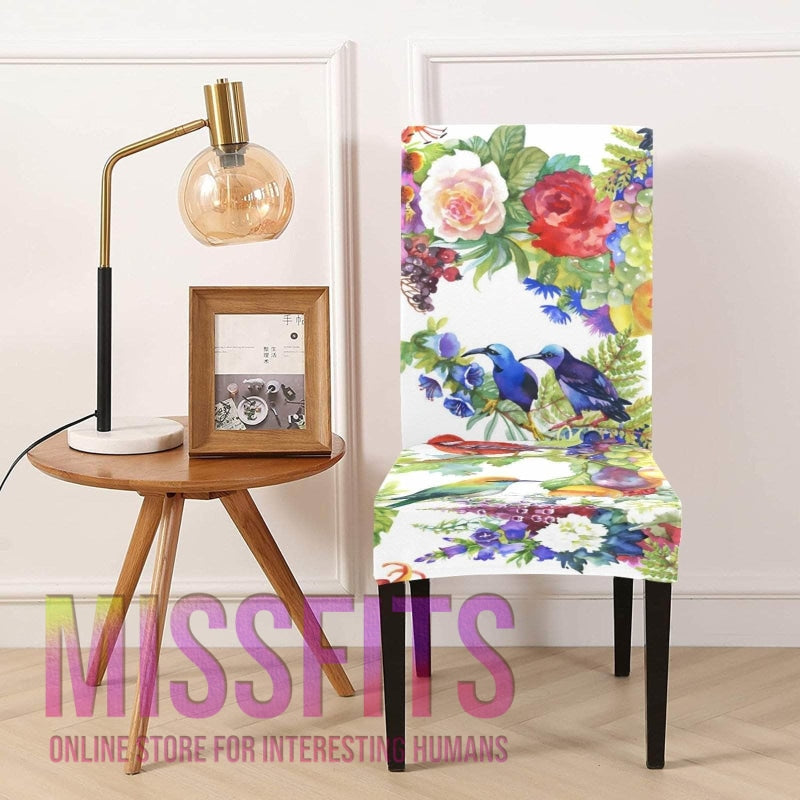What kind of atmosphere or mood does this image convey? The image conveys a lively and inviting mood, with the chair's bold and cheerful pattern serving as a statement piece against the simplicity of the room. The surrounding decor, consisting of the warm wood tones and soft lighting, adds to a cozy and creative ambience suitable for a space designed to inspire comfort and joy. 